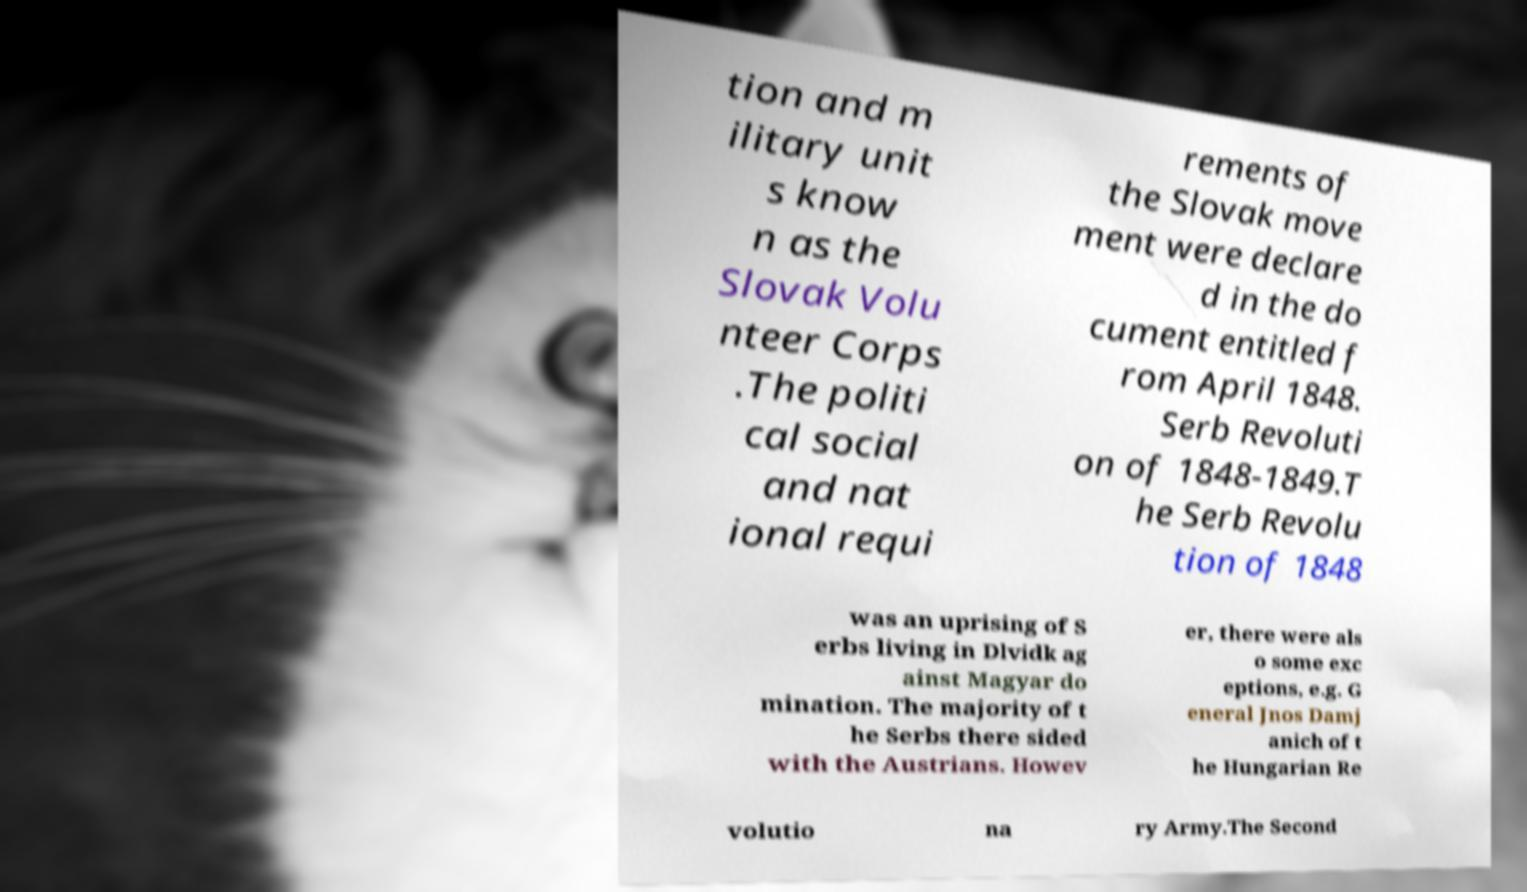Can you accurately transcribe the text from the provided image for me? tion and m ilitary unit s know n as the Slovak Volu nteer Corps .The politi cal social and nat ional requi rements of the Slovak move ment were declare d in the do cument entitled f rom April 1848. Serb Revoluti on of 1848-1849.T he Serb Revolu tion of 1848 was an uprising of S erbs living in Dlvidk ag ainst Magyar do mination. The majority of t he Serbs there sided with the Austrians. Howev er, there were als o some exc eptions, e.g. G eneral Jnos Damj anich of t he Hungarian Re volutio na ry Army.The Second 